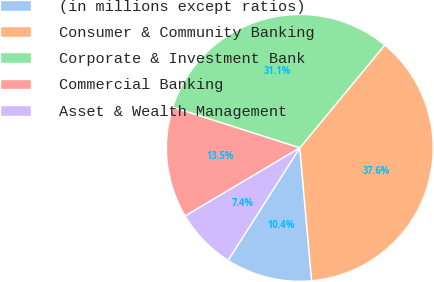Convert chart to OTSL. <chart><loc_0><loc_0><loc_500><loc_500><pie_chart><fcel>(in millions except ratios)<fcel>Consumer & Community Banking<fcel>Corporate & Investment Bank<fcel>Commercial Banking<fcel>Asset & Wealth Management<nl><fcel>10.45%<fcel>37.59%<fcel>31.07%<fcel>13.46%<fcel>7.43%<nl></chart> 